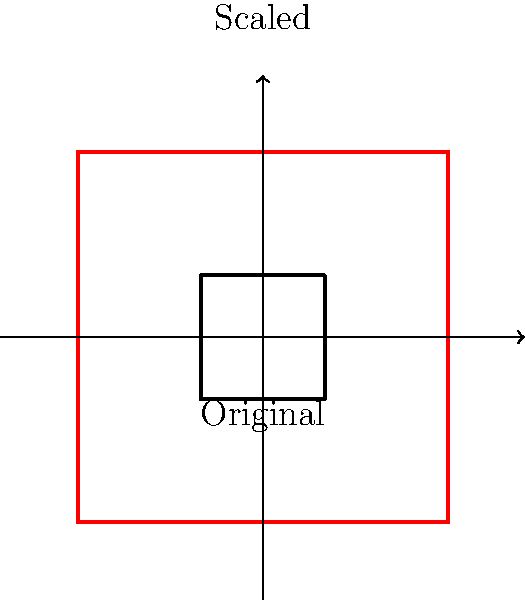In a virtual KISS trivia competition, you're asked about the transformation of the band's iconic makeup designs. If the original design of KISS's "The Demon" makeup is represented by a square with side length 2 units, and it's scaled up by a factor of 1.5, what is the area of the resulting scaled design? Let's approach this step-by-step:

1) The original design is a square with side length 2 units.
   Area of original = $2^2 = 4$ square units

2) The scaling factor is 1.5, which means all dimensions are multiplied by 1.5.
   New side length = $2 * 1.5 = 3$ units

3) To find the area of the scaled design, we square the new side length:
   Area of scaled design = $3^2 = 9$ square units

4) We can also think about this in terms of the scaling factor:
   When we scale a 2D shape by a factor of k, its area is multiplied by $k^2$.
   In this case, $k = 1.5$, so the area is multiplied by $1.5^2 = 2.25$

5) We can verify: $4 * 2.25 = 9$ square units

Therefore, the area of the scaled "The Demon" makeup design is 9 square units.
Answer: 9 square units 